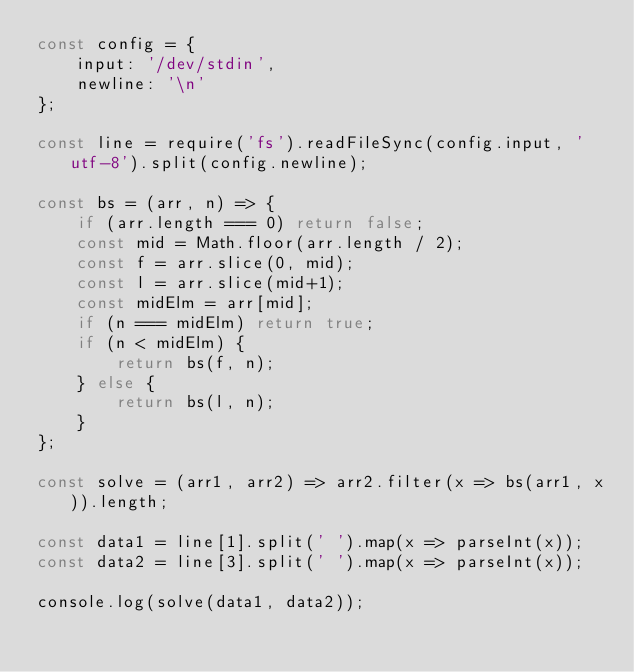<code> <loc_0><loc_0><loc_500><loc_500><_JavaScript_>const config = {
    input: '/dev/stdin',
    newline: '\n'
};

const line = require('fs').readFileSync(config.input, 'utf-8').split(config.newline);

const bs = (arr, n) => {
    if (arr.length === 0) return false;
    const mid = Math.floor(arr.length / 2);
    const f = arr.slice(0, mid);
    const l = arr.slice(mid+1);
    const midElm = arr[mid];
    if (n === midElm) return true;
    if (n < midElm) {
        return bs(f, n);
    } else {
        return bs(l, n);
    }
};

const solve = (arr1, arr2) => arr2.filter(x => bs(arr1, x)).length;

const data1 = line[1].split(' ').map(x => parseInt(x));
const data2 = line[3].split(' ').map(x => parseInt(x));

console.log(solve(data1, data2));

</code> 